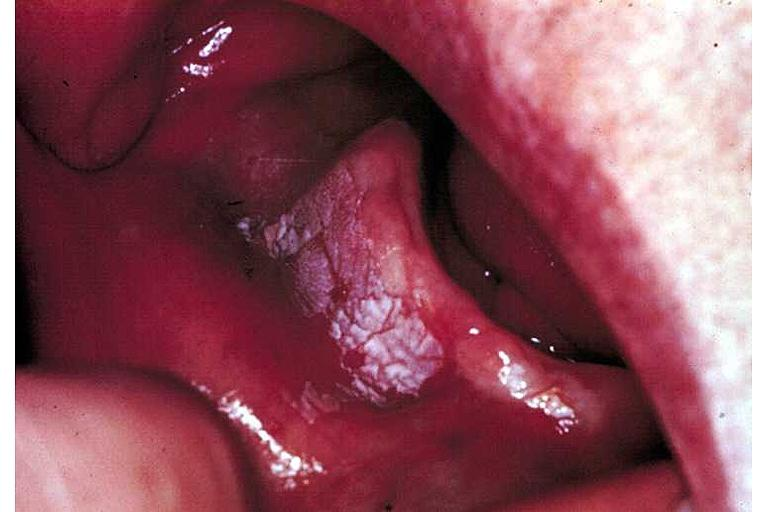s oral present?
Answer the question using a single word or phrase. Yes 